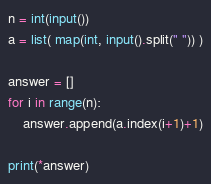Convert code to text. <code><loc_0><loc_0><loc_500><loc_500><_Python_>n = int(input())
a = list( map(int, input().split(" ")) )

answer = []
for i in range(n):
    answer.append(a.index(i+1)+1)

print(*answer)
</code> 